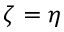<formula> <loc_0><loc_0><loc_500><loc_500>\zeta = \eta</formula> 